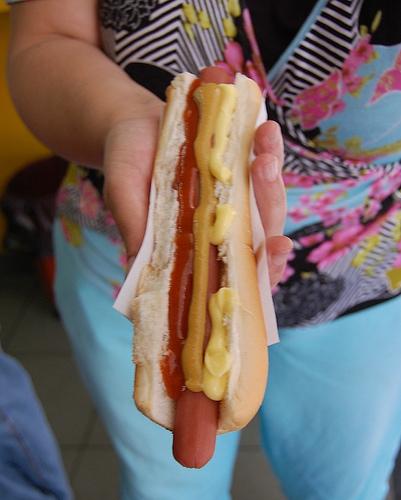What tops the hot dog?
Write a very short answer. Mustard. Is the hotdog longer than its bun?
Quick response, please. Yes. How many fingers do you see?
Write a very short answer. 4. 